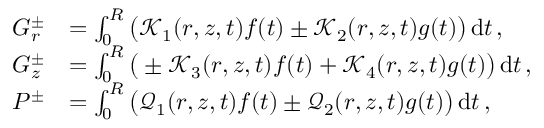Convert formula to latex. <formula><loc_0><loc_0><loc_500><loc_500>\begin{array} { r l } { G _ { r } ^ { \pm } } & { = \int _ { 0 } ^ { R } \left ( \mathcal { K } _ { 1 } ( r , z , t ) f ( t ) \pm \mathcal { K } _ { 2 } ( r , z , t ) g ( t ) \right ) \, d t \, , } \\ { G _ { z } ^ { \pm } } & { = \int _ { 0 } ^ { R } \left ( \pm \mathcal { K } _ { 3 } ( r , z , t ) f ( t ) + \mathcal { K } _ { 4 } ( r , z , t ) g ( t ) \right ) \, d t \, , } \\ { P ^ { \pm } } & { = \int _ { 0 } ^ { R } \left ( \mathcal { Q } _ { 1 } ( r , z , t ) f ( t ) \pm \mathcal { Q } _ { 2 } ( r , z , t ) g ( t ) \right ) \, d t \, , } \end{array}</formula> 